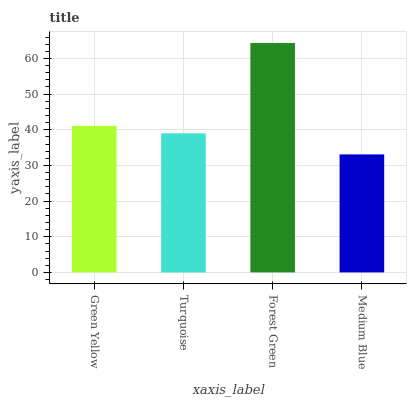Is Medium Blue the minimum?
Answer yes or no. Yes. Is Forest Green the maximum?
Answer yes or no. Yes. Is Turquoise the minimum?
Answer yes or no. No. Is Turquoise the maximum?
Answer yes or no. No. Is Green Yellow greater than Turquoise?
Answer yes or no. Yes. Is Turquoise less than Green Yellow?
Answer yes or no. Yes. Is Turquoise greater than Green Yellow?
Answer yes or no. No. Is Green Yellow less than Turquoise?
Answer yes or no. No. Is Green Yellow the high median?
Answer yes or no. Yes. Is Turquoise the low median?
Answer yes or no. Yes. Is Turquoise the high median?
Answer yes or no. No. Is Forest Green the low median?
Answer yes or no. No. 